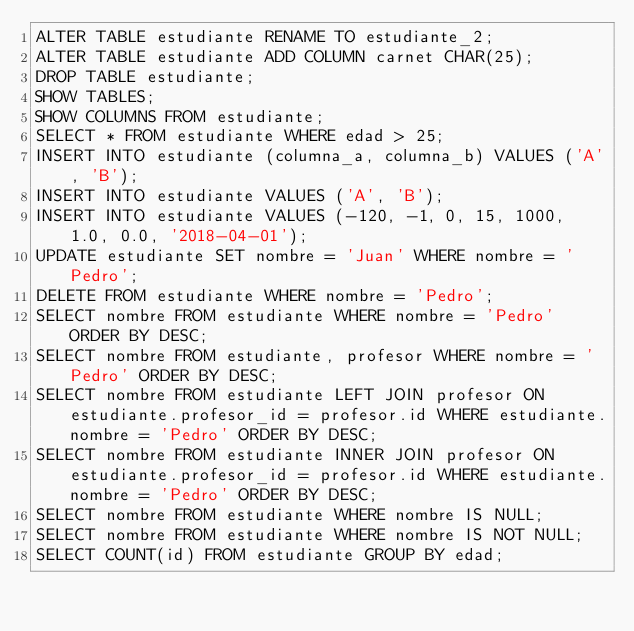Convert code to text. <code><loc_0><loc_0><loc_500><loc_500><_SQL_>ALTER TABLE estudiante RENAME TO estudiante_2;
ALTER TABLE estudiante ADD COLUMN carnet CHAR(25);
DROP TABLE estudiante;
SHOW TABLES;
SHOW COLUMNS FROM estudiante;
SELECT * FROM estudiante WHERE edad > 25;
INSERT INTO estudiante (columna_a, columna_b) VALUES ('A', 'B');
INSERT INTO estudiante VALUES ('A', 'B');
INSERT INTO estudiante VALUES (-120, -1, 0, 15, 1000, 1.0, 0.0, '2018-04-01');
UPDATE estudiante SET nombre = 'Juan' WHERE nombre = 'Pedro';
DELETE FROM estudiante WHERE nombre = 'Pedro';
SELECT nombre FROM estudiante WHERE nombre = 'Pedro' ORDER BY DESC;
SELECT nombre FROM estudiante, profesor WHERE nombre = 'Pedro' ORDER BY DESC;
SELECT nombre FROM estudiante LEFT JOIN profesor ON estudiante.profesor_id = profesor.id WHERE estudiante.nombre = 'Pedro' ORDER BY DESC;
SELECT nombre FROM estudiante INNER JOIN profesor ON estudiante.profesor_id = profesor.id WHERE estudiante.nombre = 'Pedro' ORDER BY DESC;
SELECT nombre FROM estudiante WHERE nombre IS NULL;
SELECT nombre FROM estudiante WHERE nombre IS NOT NULL;
SELECT COUNT(id) FROM estudiante GROUP BY edad;
</code> 